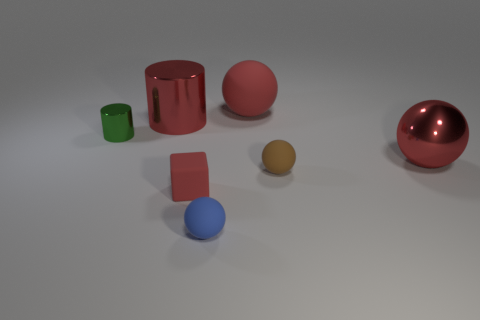Subtract all purple spheres. Subtract all blue cylinders. How many spheres are left? 4 Add 2 red shiny cylinders. How many objects exist? 9 Subtract all cubes. How many objects are left? 6 Subtract all tiny matte balls. Subtract all gray rubber things. How many objects are left? 5 Add 2 big things. How many big things are left? 5 Add 4 tiny cyan matte cubes. How many tiny cyan matte cubes exist? 4 Subtract 0 blue blocks. How many objects are left? 7 